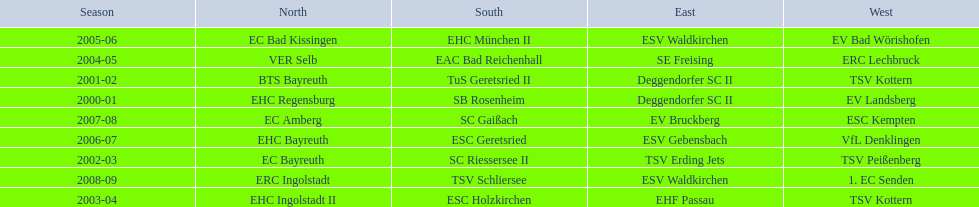What is the number of times deggendorfer sc ii is on the list? 2. Would you be able to parse every entry in this table? {'header': ['Season', 'North', 'South', 'East', 'West'], 'rows': [['2005-06', 'EC Bad Kissingen', 'EHC München II', 'ESV Waldkirchen', 'EV Bad Wörishofen'], ['2004-05', 'VER Selb', 'EAC Bad Reichenhall', 'SE Freising', 'ERC Lechbruck'], ['2001-02', 'BTS Bayreuth', 'TuS Geretsried II', 'Deggendorfer SC II', 'TSV Kottern'], ['2000-01', 'EHC Regensburg', 'SB Rosenheim', 'Deggendorfer SC II', 'EV Landsberg'], ['2007-08', 'EC Amberg', 'SC Gaißach', 'EV Bruckberg', 'ESC Kempten'], ['2006-07', 'EHC Bayreuth', 'ESC Geretsried', 'ESV Gebensbach', 'VfL Denklingen'], ['2002-03', 'EC Bayreuth', 'SC Riessersee II', 'TSV Erding Jets', 'TSV Peißenberg'], ['2008-09', 'ERC Ingolstadt', 'TSV Schliersee', 'ESV Waldkirchen', '1. EC Senden'], ['2003-04', 'EHC Ingolstadt II', 'ESC Holzkirchen', 'EHF Passau', 'TSV Kottern']]} 